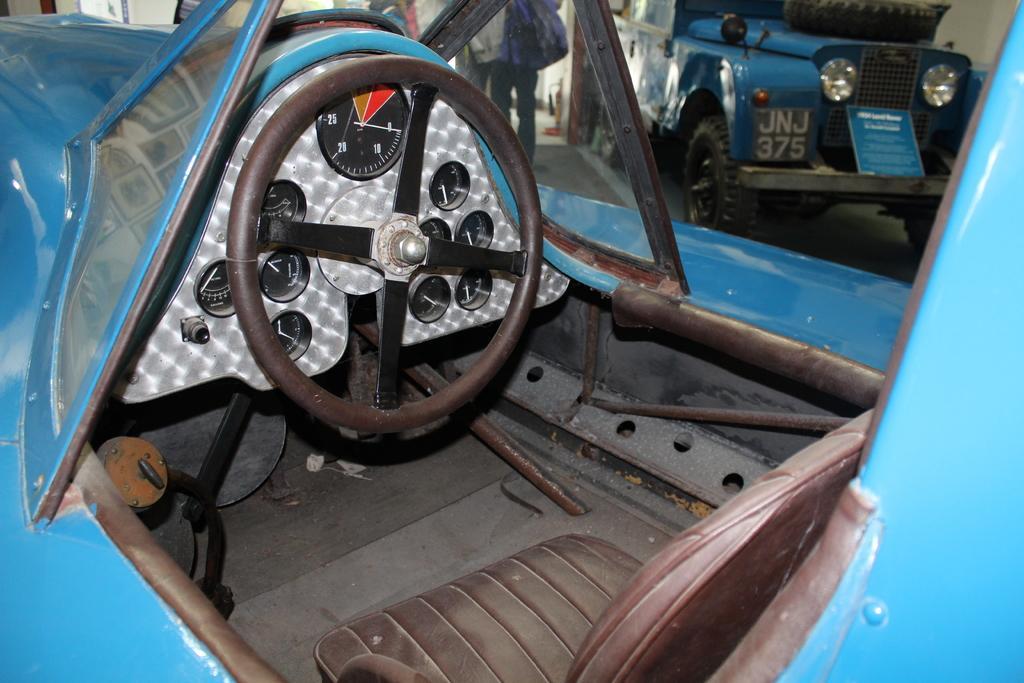Please provide a concise description of this image. In this image, we can see an inside view of a vehicle. Here we can see steering, odometers, few rods, glass objects and seat. Top of the image, we can see few people, vehicle, wall, tyre, board and floor. 